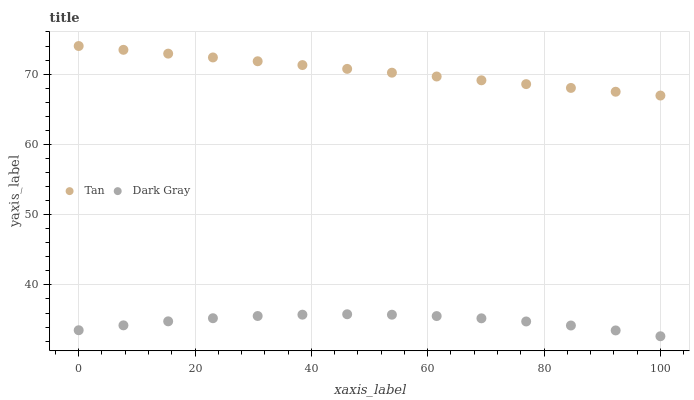Does Dark Gray have the minimum area under the curve?
Answer yes or no. Yes. Does Tan have the maximum area under the curve?
Answer yes or no. Yes. Does Tan have the minimum area under the curve?
Answer yes or no. No. Is Tan the smoothest?
Answer yes or no. Yes. Is Dark Gray the roughest?
Answer yes or no. Yes. Is Tan the roughest?
Answer yes or no. No. Does Dark Gray have the lowest value?
Answer yes or no. Yes. Does Tan have the lowest value?
Answer yes or no. No. Does Tan have the highest value?
Answer yes or no. Yes. Is Dark Gray less than Tan?
Answer yes or no. Yes. Is Tan greater than Dark Gray?
Answer yes or no. Yes. Does Dark Gray intersect Tan?
Answer yes or no. No. 